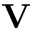Convert formula to latex. <formula><loc_0><loc_0><loc_500><loc_500>{ V }</formula> 